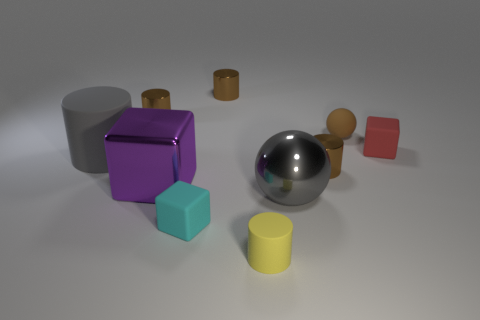Subtract all green balls. How many brown cylinders are left? 3 Subtract 1 cylinders. How many cylinders are left? 4 Subtract all yellow cylinders. How many cylinders are left? 4 Subtract all large gray cylinders. How many cylinders are left? 4 Subtract all cyan cylinders. Subtract all purple cubes. How many cylinders are left? 5 Subtract all blocks. How many objects are left? 7 Add 7 yellow matte cylinders. How many yellow matte cylinders exist? 8 Subtract 0 purple cylinders. How many objects are left? 10 Subtract all big spheres. Subtract all tiny brown cylinders. How many objects are left? 6 Add 1 yellow rubber objects. How many yellow rubber objects are left? 2 